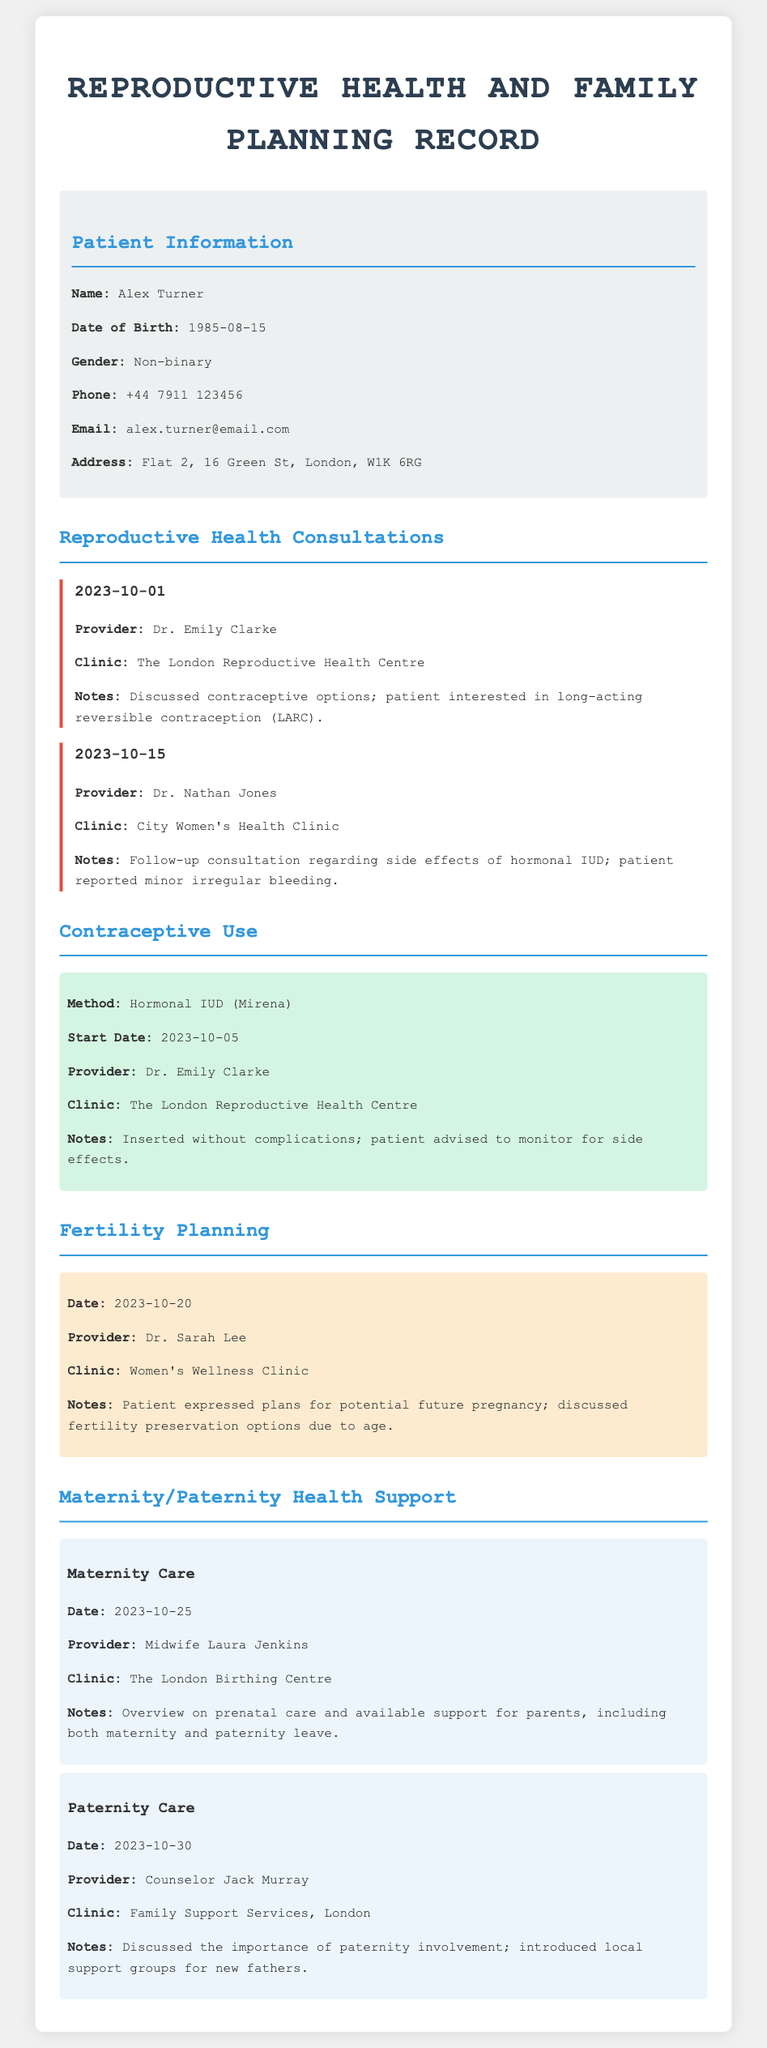What is the patient's name? The patient's name is listed at the beginning of the document under Patient Information.
Answer: Alex Turner When was the hormonal IUD inserted? The insertion date for the hormonal IUD is noted in the Contraceptive Use section.
Answer: 2023-10-05 Who provided maternity care? The provider's name for maternity care is mentioned in the Maternity/Paternity Health Support section.
Answer: Midwife Laura Jenkins What method of contraception was discussed on 2023-10-01? The method of contraception is specified in the Reproductive Health Consultations section for that date.
Answer: Long-acting reversible contraception (LARC) Which clinic was visited on 2023-10-20? The clinic visited for fertility planning is documented in the Fertility Planning section.
Answer: Women's Wellness Clinic What support was discussed for new fathers? The specific support mentioned for new fathers is detailed in the Paternity Care section.
Answer: Local support groups for new fathers How many consultations are noted in the document? The total number of consultations is counted from the consultation sections.
Answer: 2 What date is associated with the follow-up consultation for the hormonal IUD? The follow-up consultation date for the hormonal IUD is specified in the second consultation entry.
Answer: 2023-10-15 